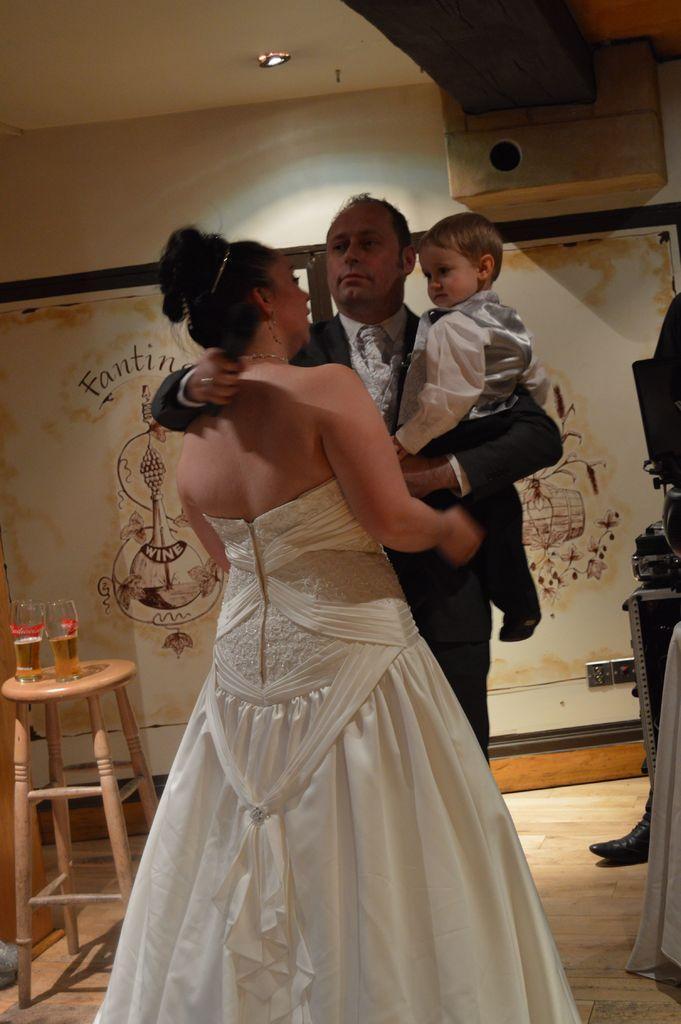How would you summarize this image in a sentence or two? Here we see a man and woman standing. man holding a boy in his hand and we see a table on the table we see two wine glasses. 